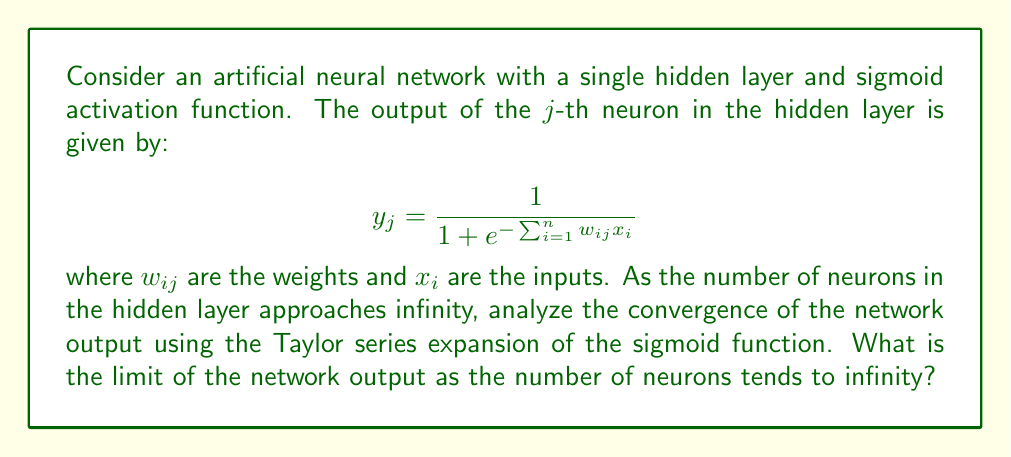Show me your answer to this math problem. 1) First, let's recall the Taylor series expansion of the sigmoid function around x = 0:

   $$\sigma(x) = \frac{1}{1+e^{-x}} = \frac{1}{2} + \frac{x}{4} - \frac{x^3}{48} + O(x^5)$$

2) For small values of $\sum_{i=1}^n w_{ij}x_i$, we can approximate the output of each neuron as:

   $$y_j \approx \frac{1}{2} + \frac{\sum_{i=1}^n w_{ij}x_i}{4} - \frac{(\sum_{i=1}^n w_{ij}x_i)^3}{48} + O((\sum_{i=1}^n w_{ij}x_i)^5)$$

3) The output of the network is typically a weighted sum of these neuron outputs:

   $$f(x) = \sum_{j=1}^m v_j y_j$$

   where $m$ is the number of neurons in the hidden layer and $v_j$ are the output weights.

4) Substituting the approximation for $y_j$:

   $$f(x) \approx \sum_{j=1}^m v_j (\frac{1}{2} + \frac{\sum_{i=1}^n w_{ij}x_i}{4} - \frac{(\sum_{i=1}^n w_{ij}x_i)^3}{48} + O((\sum_{i=1}^n w_{ij}x_i)^5))$$

5) As $m \to \infty$, we need to consider how the weights scale. Typically, for convergence, we scale the weights as $v_j = O(\frac{1}{m})$ and $w_{ij} = O(\frac{1}{\sqrt{m}})$.

6) With this scaling, as $m \to \infty$:
   - The first term becomes: $\frac{1}{2}\sum_{j=1}^m v_j \to \frac{1}{2}c_1$, where $c_1$ is a constant.
   - The second term becomes: $\frac{1}{4}\sum_{j=1}^m v_j \sum_{i=1}^n w_{ij}x_i \to c_2$, where $c_2$ is a function of $x$.
   - The third and higher-order terms approach zero due to the scaling of the weights.

7) Therefore, as $m \to \infty$, the network output converges to:

   $$\lim_{m \to \infty} f(x) = \frac{1}{2}c_1 + c_2$$

   which is a linear function of the inputs $x$.
Answer: $\frac{1}{2}c_1 + c_2$, where $c_1$ is a constant and $c_2$ is a linear function of the inputs. 